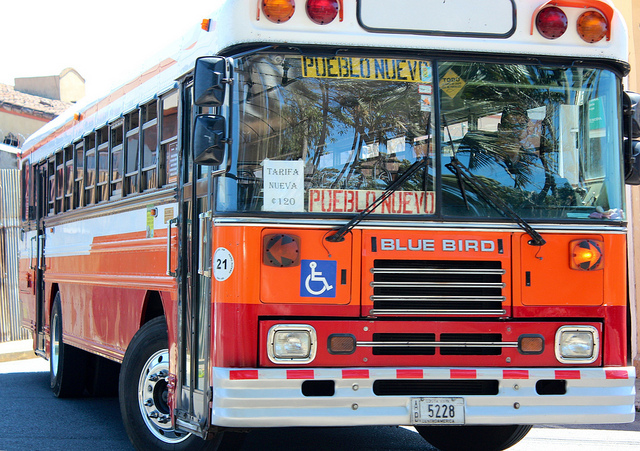Please transcribe the text information in this image. PUEBLO NUEVO BLUE BIRD 5228 A B 21 PUEBLONUEVO 120 SUEVA TARIFA 